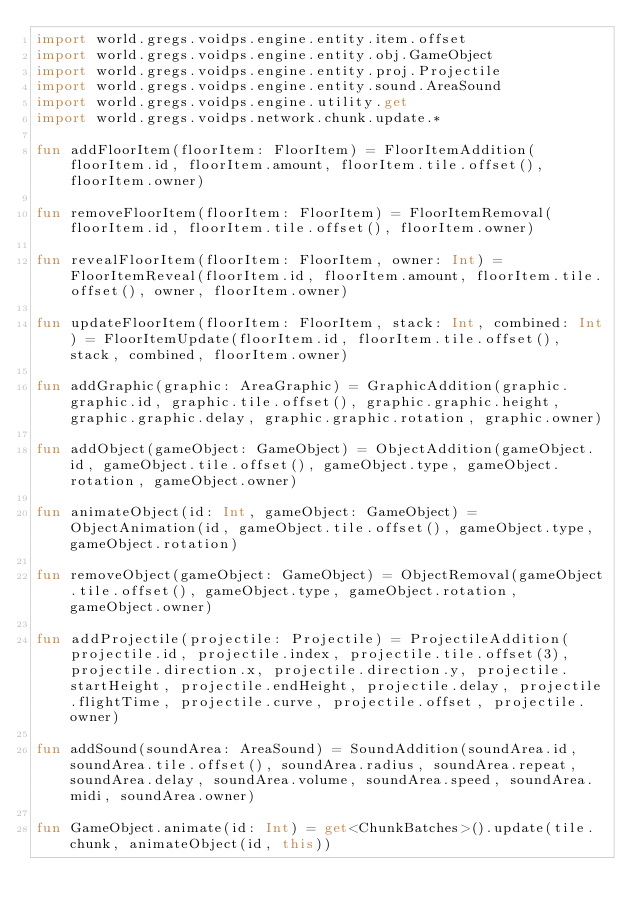Convert code to text. <code><loc_0><loc_0><loc_500><loc_500><_Kotlin_>import world.gregs.voidps.engine.entity.item.offset
import world.gregs.voidps.engine.entity.obj.GameObject
import world.gregs.voidps.engine.entity.proj.Projectile
import world.gregs.voidps.engine.entity.sound.AreaSound
import world.gregs.voidps.engine.utility.get
import world.gregs.voidps.network.chunk.update.*

fun addFloorItem(floorItem: FloorItem) = FloorItemAddition(floorItem.id, floorItem.amount, floorItem.tile.offset(), floorItem.owner)

fun removeFloorItem(floorItem: FloorItem) = FloorItemRemoval(floorItem.id, floorItem.tile.offset(), floorItem.owner)

fun revealFloorItem(floorItem: FloorItem, owner: Int) = FloorItemReveal(floorItem.id, floorItem.amount, floorItem.tile.offset(), owner, floorItem.owner)

fun updateFloorItem(floorItem: FloorItem, stack: Int, combined: Int) = FloorItemUpdate(floorItem.id, floorItem.tile.offset(), stack, combined, floorItem.owner)

fun addGraphic(graphic: AreaGraphic) = GraphicAddition(graphic.graphic.id, graphic.tile.offset(), graphic.graphic.height, graphic.graphic.delay, graphic.graphic.rotation, graphic.owner)

fun addObject(gameObject: GameObject) = ObjectAddition(gameObject.id, gameObject.tile.offset(), gameObject.type, gameObject.rotation, gameObject.owner)

fun animateObject(id: Int, gameObject: GameObject) = ObjectAnimation(id, gameObject.tile.offset(), gameObject.type, gameObject.rotation)

fun removeObject(gameObject: GameObject) = ObjectRemoval(gameObject.tile.offset(), gameObject.type, gameObject.rotation, gameObject.owner)

fun addProjectile(projectile: Projectile) = ProjectileAddition(projectile.id, projectile.index, projectile.tile.offset(3), projectile.direction.x, projectile.direction.y, projectile.startHeight, projectile.endHeight, projectile.delay, projectile.flightTime, projectile.curve, projectile.offset, projectile.owner)

fun addSound(soundArea: AreaSound) = SoundAddition(soundArea.id, soundArea.tile.offset(), soundArea.radius, soundArea.repeat, soundArea.delay, soundArea.volume, soundArea.speed, soundArea.midi, soundArea.owner)

fun GameObject.animate(id: Int) = get<ChunkBatches>().update(tile.chunk, animateObject(id, this))</code> 